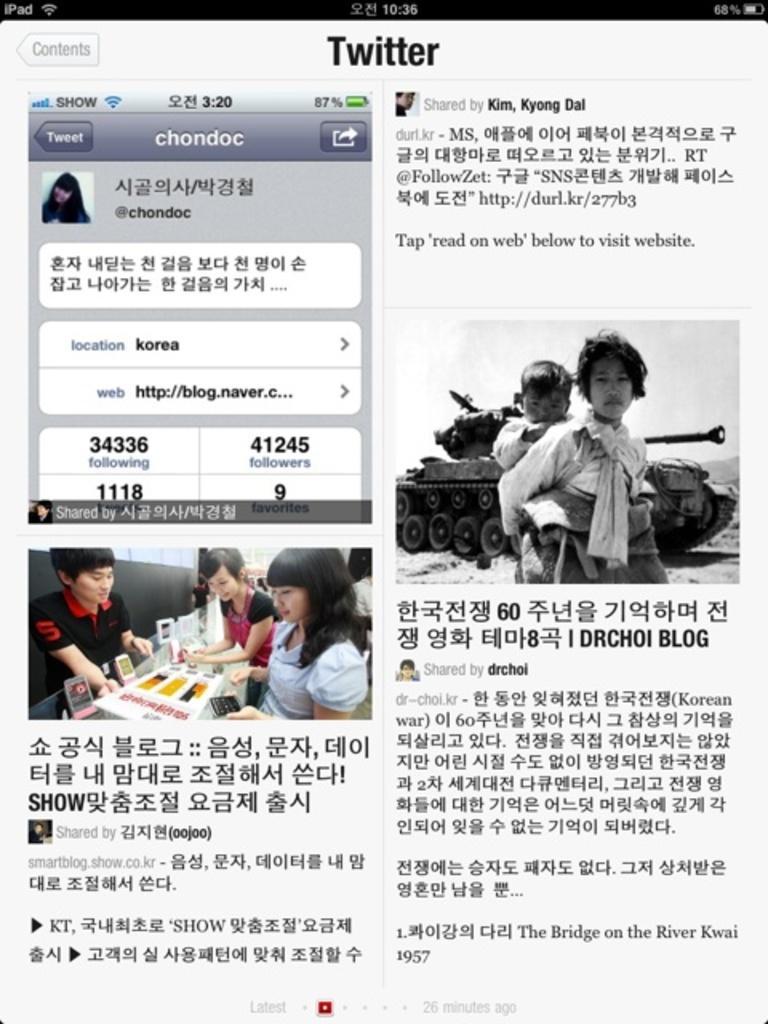Please provide a concise description of this image. In this image I can see a web page. We can see image and something is written on the web page. 